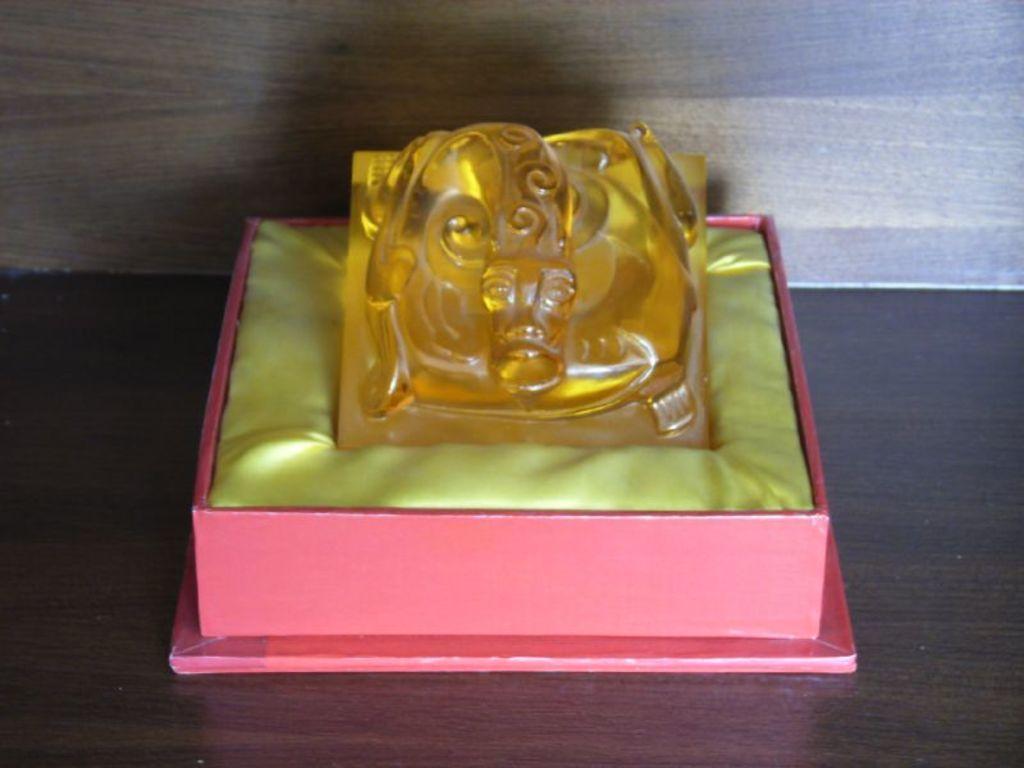Can you describe this image briefly? In this image we can see a box and an object on a wooden platform. 